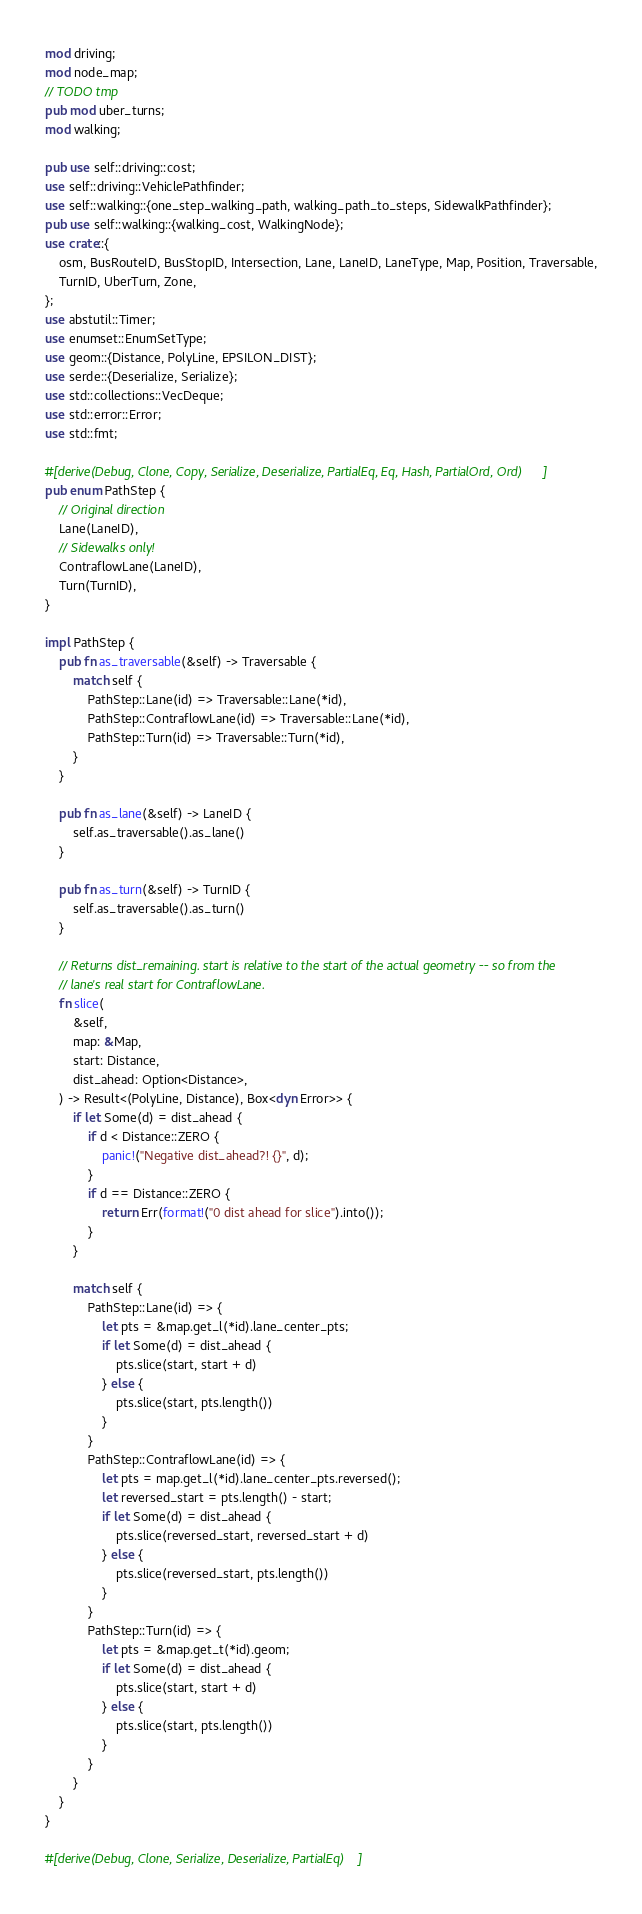<code> <loc_0><loc_0><loc_500><loc_500><_Rust_>mod driving;
mod node_map;
// TODO tmp
pub mod uber_turns;
mod walking;

pub use self::driving::cost;
use self::driving::VehiclePathfinder;
use self::walking::{one_step_walking_path, walking_path_to_steps, SidewalkPathfinder};
pub use self::walking::{walking_cost, WalkingNode};
use crate::{
    osm, BusRouteID, BusStopID, Intersection, Lane, LaneID, LaneType, Map, Position, Traversable,
    TurnID, UberTurn, Zone,
};
use abstutil::Timer;
use enumset::EnumSetType;
use geom::{Distance, PolyLine, EPSILON_DIST};
use serde::{Deserialize, Serialize};
use std::collections::VecDeque;
use std::error::Error;
use std::fmt;

#[derive(Debug, Clone, Copy, Serialize, Deserialize, PartialEq, Eq, Hash, PartialOrd, Ord)]
pub enum PathStep {
    // Original direction
    Lane(LaneID),
    // Sidewalks only!
    ContraflowLane(LaneID),
    Turn(TurnID),
}

impl PathStep {
    pub fn as_traversable(&self) -> Traversable {
        match self {
            PathStep::Lane(id) => Traversable::Lane(*id),
            PathStep::ContraflowLane(id) => Traversable::Lane(*id),
            PathStep::Turn(id) => Traversable::Turn(*id),
        }
    }

    pub fn as_lane(&self) -> LaneID {
        self.as_traversable().as_lane()
    }

    pub fn as_turn(&self) -> TurnID {
        self.as_traversable().as_turn()
    }

    // Returns dist_remaining. start is relative to the start of the actual geometry -- so from the
    // lane's real start for ContraflowLane.
    fn slice(
        &self,
        map: &Map,
        start: Distance,
        dist_ahead: Option<Distance>,
    ) -> Result<(PolyLine, Distance), Box<dyn Error>> {
        if let Some(d) = dist_ahead {
            if d < Distance::ZERO {
                panic!("Negative dist_ahead?! {}", d);
            }
            if d == Distance::ZERO {
                return Err(format!("0 dist ahead for slice").into());
            }
        }

        match self {
            PathStep::Lane(id) => {
                let pts = &map.get_l(*id).lane_center_pts;
                if let Some(d) = dist_ahead {
                    pts.slice(start, start + d)
                } else {
                    pts.slice(start, pts.length())
                }
            }
            PathStep::ContraflowLane(id) => {
                let pts = map.get_l(*id).lane_center_pts.reversed();
                let reversed_start = pts.length() - start;
                if let Some(d) = dist_ahead {
                    pts.slice(reversed_start, reversed_start + d)
                } else {
                    pts.slice(reversed_start, pts.length())
                }
            }
            PathStep::Turn(id) => {
                let pts = &map.get_t(*id).geom;
                if let Some(d) = dist_ahead {
                    pts.slice(start, start + d)
                } else {
                    pts.slice(start, pts.length())
                }
            }
        }
    }
}

#[derive(Debug, Clone, Serialize, Deserialize, PartialEq)]</code> 